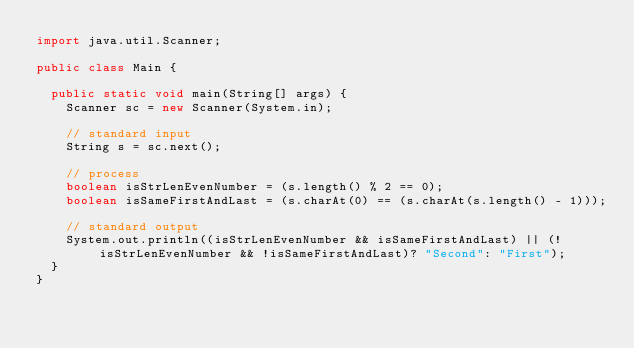<code> <loc_0><loc_0><loc_500><loc_500><_Java_>import java.util.Scanner;

public class Main {

	public static void main(String[] args) {
		Scanner sc = new Scanner(System.in);

		// standard input
		String s = sc.next();

		// process
		boolean isStrLenEvenNumber = (s.length() % 2 == 0);
		boolean isSameFirstAndLast = (s.charAt(0) == (s.charAt(s.length() - 1)));

		// standard output
		System.out.println((isStrLenEvenNumber && isSameFirstAndLast) || (!isStrLenEvenNumber && !isSameFirstAndLast)? "Second": "First");
	}
}
</code> 